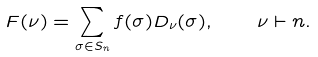Convert formula to latex. <formula><loc_0><loc_0><loc_500><loc_500>F ( \nu ) = \sum _ { \sigma \in S _ { n } } f ( \sigma ) D _ { \nu } ( \sigma ) , \quad \nu \vdash n .</formula> 